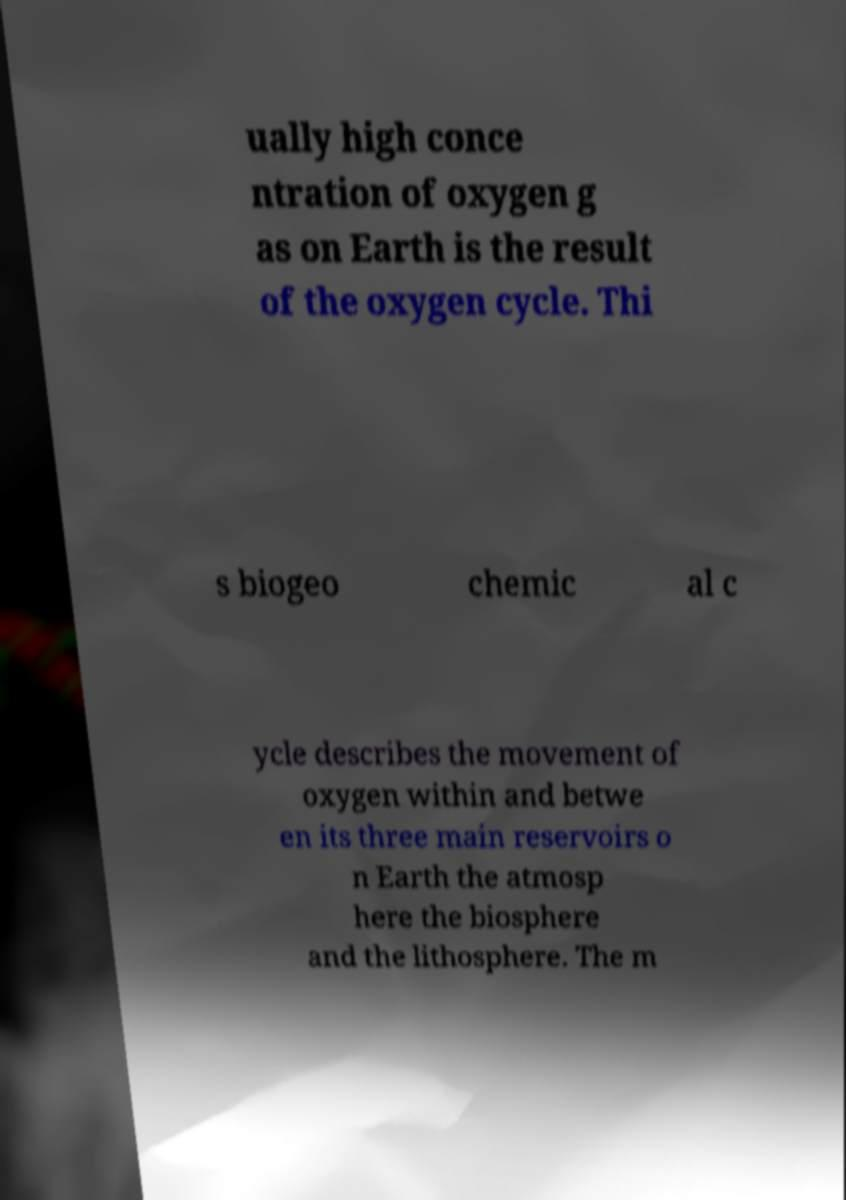Could you extract and type out the text from this image? ually high conce ntration of oxygen g as on Earth is the result of the oxygen cycle. Thi s biogeo chemic al c ycle describes the movement of oxygen within and betwe en its three main reservoirs o n Earth the atmosp here the biosphere and the lithosphere. The m 